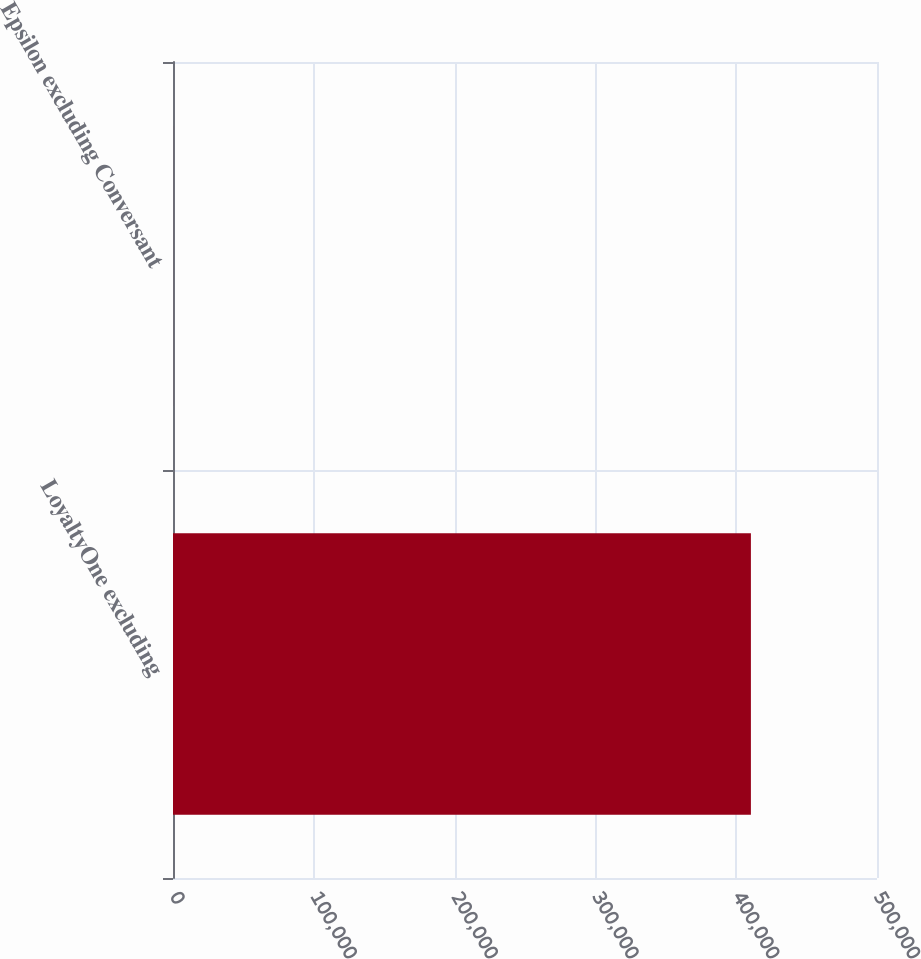Convert chart. <chart><loc_0><loc_0><loc_500><loc_500><bar_chart><fcel>LoyaltyOne excluding<fcel>Epsilon excluding Conversant<nl><fcel>410440<fcel>30<nl></chart> 